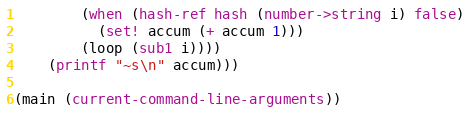<code> <loc_0><loc_0><loc_500><loc_500><_Racket_>        (when (hash-ref hash (number->string i) false)
          (set! accum (+ accum 1)))
        (loop (sub1 i))))
    (printf "~s\n" accum)))

(main (current-command-line-arguments))
</code> 